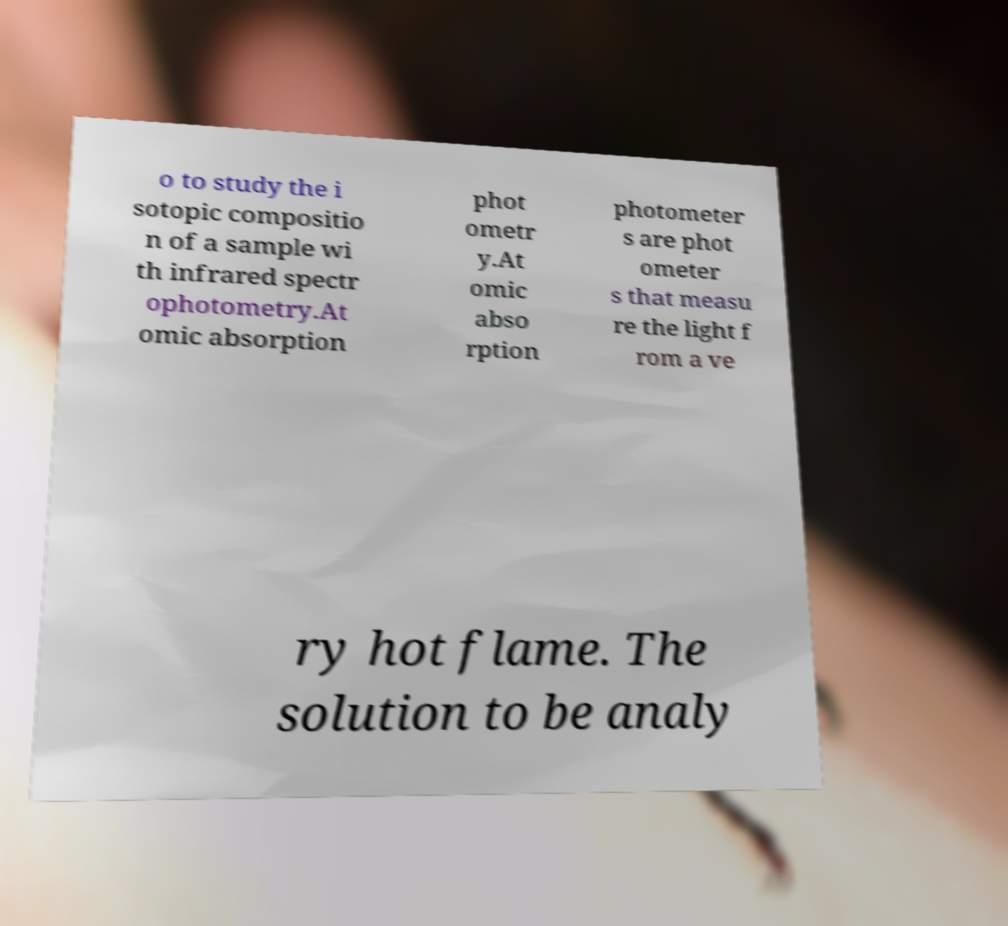Please read and relay the text visible in this image. What does it say? o to study the i sotopic compositio n of a sample wi th infrared spectr ophotometry.At omic absorption phot ometr y.At omic abso rption photometer s are phot ometer s that measu re the light f rom a ve ry hot flame. The solution to be analy 